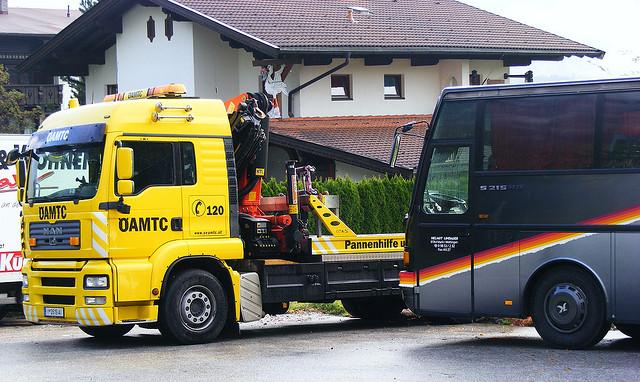What kind of vehicle is the yellow one?
Concise answer only. Truck. How many windows?
Keep it brief. 11. Is this a hotel?
Short answer required. No. 